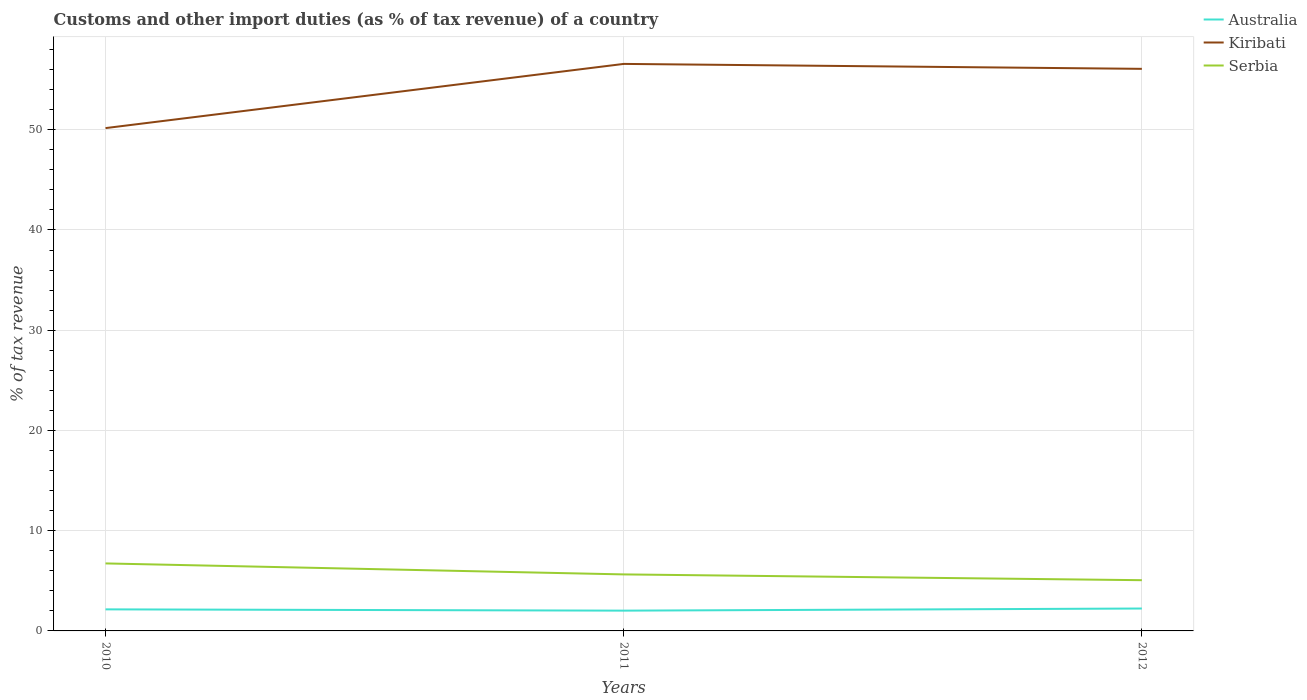How many different coloured lines are there?
Provide a short and direct response. 3. Does the line corresponding to Australia intersect with the line corresponding to Serbia?
Your answer should be very brief. No. Across all years, what is the maximum percentage of tax revenue from customs in Australia?
Your answer should be compact. 2.02. In which year was the percentage of tax revenue from customs in Kiribati maximum?
Your response must be concise. 2010. What is the total percentage of tax revenue from customs in Australia in the graph?
Your answer should be compact. 0.13. What is the difference between the highest and the second highest percentage of tax revenue from customs in Kiribati?
Make the answer very short. 6.4. How many lines are there?
Ensure brevity in your answer.  3. How many years are there in the graph?
Keep it short and to the point. 3. What is the difference between two consecutive major ticks on the Y-axis?
Make the answer very short. 10. Does the graph contain any zero values?
Your response must be concise. No. Does the graph contain grids?
Your answer should be very brief. Yes. Where does the legend appear in the graph?
Provide a succinct answer. Top right. What is the title of the graph?
Ensure brevity in your answer.  Customs and other import duties (as % of tax revenue) of a country. Does "Greece" appear as one of the legend labels in the graph?
Ensure brevity in your answer.  No. What is the label or title of the X-axis?
Your response must be concise. Years. What is the label or title of the Y-axis?
Provide a succinct answer. % of tax revenue. What is the % of tax revenue of Australia in 2010?
Make the answer very short. 2.15. What is the % of tax revenue in Kiribati in 2010?
Ensure brevity in your answer.  50.17. What is the % of tax revenue in Serbia in 2010?
Ensure brevity in your answer.  6.73. What is the % of tax revenue of Australia in 2011?
Provide a succinct answer. 2.02. What is the % of tax revenue of Kiribati in 2011?
Make the answer very short. 56.57. What is the % of tax revenue of Serbia in 2011?
Provide a short and direct response. 5.64. What is the % of tax revenue of Australia in 2012?
Provide a short and direct response. 2.24. What is the % of tax revenue in Kiribati in 2012?
Keep it short and to the point. 56.08. What is the % of tax revenue in Serbia in 2012?
Make the answer very short. 5.06. Across all years, what is the maximum % of tax revenue in Australia?
Offer a terse response. 2.24. Across all years, what is the maximum % of tax revenue of Kiribati?
Your answer should be very brief. 56.57. Across all years, what is the maximum % of tax revenue of Serbia?
Offer a terse response. 6.73. Across all years, what is the minimum % of tax revenue in Australia?
Your response must be concise. 2.02. Across all years, what is the minimum % of tax revenue in Kiribati?
Offer a terse response. 50.17. Across all years, what is the minimum % of tax revenue of Serbia?
Offer a very short reply. 5.06. What is the total % of tax revenue of Australia in the graph?
Offer a terse response. 6.41. What is the total % of tax revenue in Kiribati in the graph?
Your response must be concise. 162.81. What is the total % of tax revenue of Serbia in the graph?
Ensure brevity in your answer.  17.43. What is the difference between the % of tax revenue of Australia in 2010 and that in 2011?
Your response must be concise. 0.13. What is the difference between the % of tax revenue of Kiribati in 2010 and that in 2011?
Ensure brevity in your answer.  -6.4. What is the difference between the % of tax revenue of Serbia in 2010 and that in 2011?
Keep it short and to the point. 1.1. What is the difference between the % of tax revenue of Australia in 2010 and that in 2012?
Make the answer very short. -0.08. What is the difference between the % of tax revenue of Kiribati in 2010 and that in 2012?
Make the answer very short. -5.91. What is the difference between the % of tax revenue of Serbia in 2010 and that in 2012?
Offer a very short reply. 1.67. What is the difference between the % of tax revenue of Australia in 2011 and that in 2012?
Provide a succinct answer. -0.21. What is the difference between the % of tax revenue of Kiribati in 2011 and that in 2012?
Your answer should be compact. 0.49. What is the difference between the % of tax revenue of Serbia in 2011 and that in 2012?
Ensure brevity in your answer.  0.58. What is the difference between the % of tax revenue of Australia in 2010 and the % of tax revenue of Kiribati in 2011?
Ensure brevity in your answer.  -54.42. What is the difference between the % of tax revenue in Australia in 2010 and the % of tax revenue in Serbia in 2011?
Your answer should be very brief. -3.49. What is the difference between the % of tax revenue in Kiribati in 2010 and the % of tax revenue in Serbia in 2011?
Your response must be concise. 44.53. What is the difference between the % of tax revenue in Australia in 2010 and the % of tax revenue in Kiribati in 2012?
Make the answer very short. -53.93. What is the difference between the % of tax revenue in Australia in 2010 and the % of tax revenue in Serbia in 2012?
Give a very brief answer. -2.91. What is the difference between the % of tax revenue in Kiribati in 2010 and the % of tax revenue in Serbia in 2012?
Offer a very short reply. 45.1. What is the difference between the % of tax revenue in Australia in 2011 and the % of tax revenue in Kiribati in 2012?
Make the answer very short. -54.05. What is the difference between the % of tax revenue of Australia in 2011 and the % of tax revenue of Serbia in 2012?
Provide a short and direct response. -3.04. What is the difference between the % of tax revenue of Kiribati in 2011 and the % of tax revenue of Serbia in 2012?
Keep it short and to the point. 51.51. What is the average % of tax revenue in Australia per year?
Provide a succinct answer. 2.14. What is the average % of tax revenue in Kiribati per year?
Provide a short and direct response. 54.27. What is the average % of tax revenue in Serbia per year?
Your answer should be compact. 5.81. In the year 2010, what is the difference between the % of tax revenue in Australia and % of tax revenue in Kiribati?
Make the answer very short. -48.01. In the year 2010, what is the difference between the % of tax revenue of Australia and % of tax revenue of Serbia?
Offer a terse response. -4.58. In the year 2010, what is the difference between the % of tax revenue of Kiribati and % of tax revenue of Serbia?
Ensure brevity in your answer.  43.43. In the year 2011, what is the difference between the % of tax revenue of Australia and % of tax revenue of Kiribati?
Provide a succinct answer. -54.55. In the year 2011, what is the difference between the % of tax revenue of Australia and % of tax revenue of Serbia?
Make the answer very short. -3.61. In the year 2011, what is the difference between the % of tax revenue in Kiribati and % of tax revenue in Serbia?
Your answer should be compact. 50.93. In the year 2012, what is the difference between the % of tax revenue in Australia and % of tax revenue in Kiribati?
Your answer should be very brief. -53.84. In the year 2012, what is the difference between the % of tax revenue in Australia and % of tax revenue in Serbia?
Your response must be concise. -2.83. In the year 2012, what is the difference between the % of tax revenue in Kiribati and % of tax revenue in Serbia?
Give a very brief answer. 51.02. What is the ratio of the % of tax revenue of Australia in 2010 to that in 2011?
Give a very brief answer. 1.06. What is the ratio of the % of tax revenue of Kiribati in 2010 to that in 2011?
Make the answer very short. 0.89. What is the ratio of the % of tax revenue of Serbia in 2010 to that in 2011?
Your answer should be very brief. 1.19. What is the ratio of the % of tax revenue in Australia in 2010 to that in 2012?
Provide a short and direct response. 0.96. What is the ratio of the % of tax revenue in Kiribati in 2010 to that in 2012?
Offer a very short reply. 0.89. What is the ratio of the % of tax revenue in Serbia in 2010 to that in 2012?
Make the answer very short. 1.33. What is the ratio of the % of tax revenue of Australia in 2011 to that in 2012?
Keep it short and to the point. 0.91. What is the ratio of the % of tax revenue of Kiribati in 2011 to that in 2012?
Keep it short and to the point. 1.01. What is the ratio of the % of tax revenue in Serbia in 2011 to that in 2012?
Ensure brevity in your answer.  1.11. What is the difference between the highest and the second highest % of tax revenue in Australia?
Offer a very short reply. 0.08. What is the difference between the highest and the second highest % of tax revenue in Kiribati?
Give a very brief answer. 0.49. What is the difference between the highest and the second highest % of tax revenue of Serbia?
Give a very brief answer. 1.1. What is the difference between the highest and the lowest % of tax revenue in Australia?
Ensure brevity in your answer.  0.21. What is the difference between the highest and the lowest % of tax revenue of Kiribati?
Ensure brevity in your answer.  6.4. What is the difference between the highest and the lowest % of tax revenue in Serbia?
Keep it short and to the point. 1.67. 